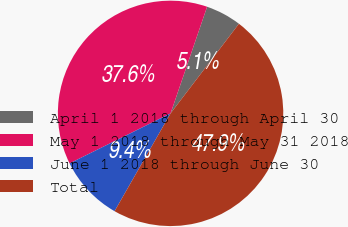Convert chart to OTSL. <chart><loc_0><loc_0><loc_500><loc_500><pie_chart><fcel>April 1 2018 through April 30<fcel>May 1 2018 through May 31 2018<fcel>June 1 2018 through June 30<fcel>Total<nl><fcel>5.12%<fcel>37.57%<fcel>9.4%<fcel>47.9%<nl></chart> 